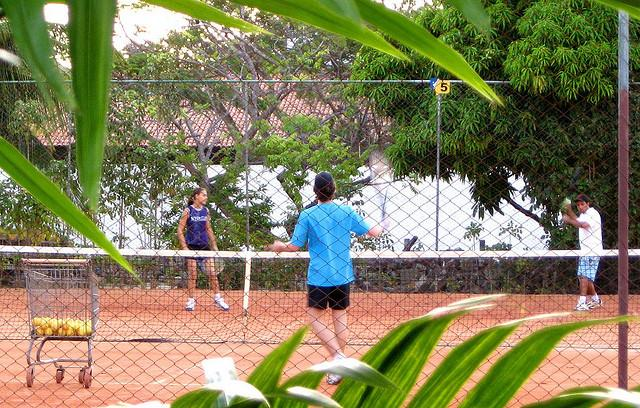What are the tennis balls in the cart for? Please explain your reasoning. training. Their lack of uniform indicates that they are just practicing, and many balls are needed in order to save time from running after the balk each time. 